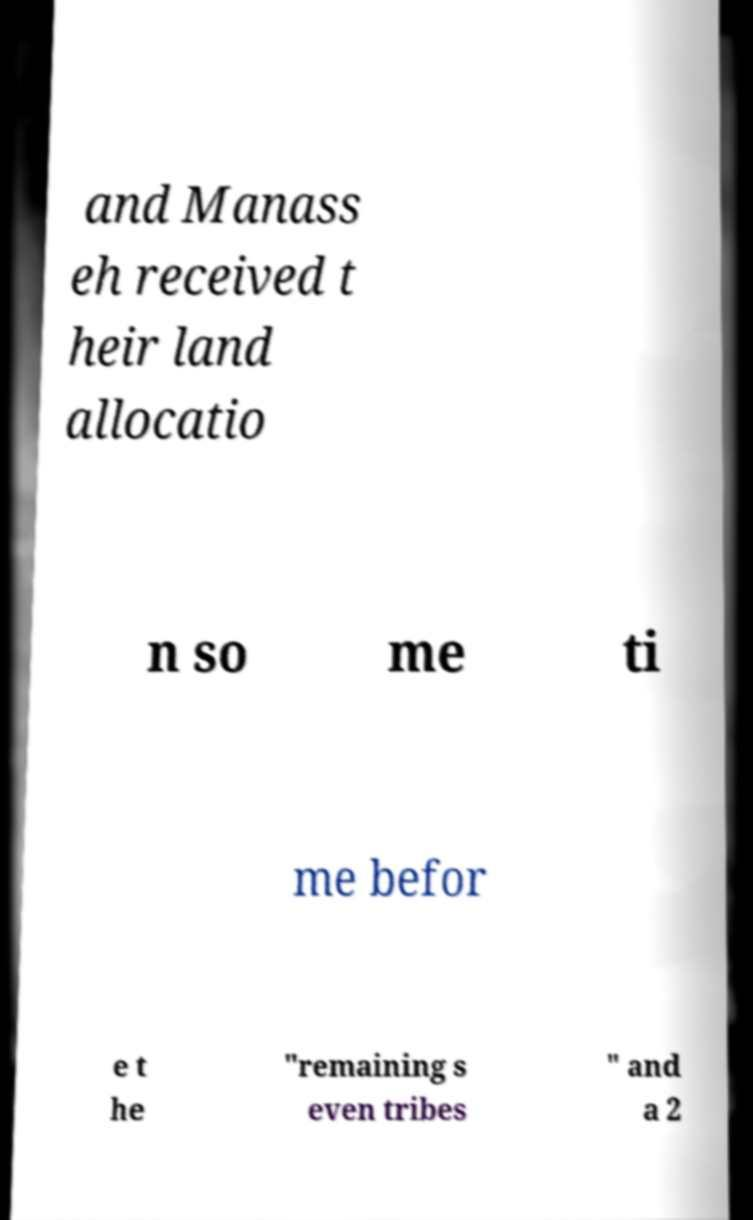Could you extract and type out the text from this image? and Manass eh received t heir land allocatio n so me ti me befor e t he "remaining s even tribes " and a 2 